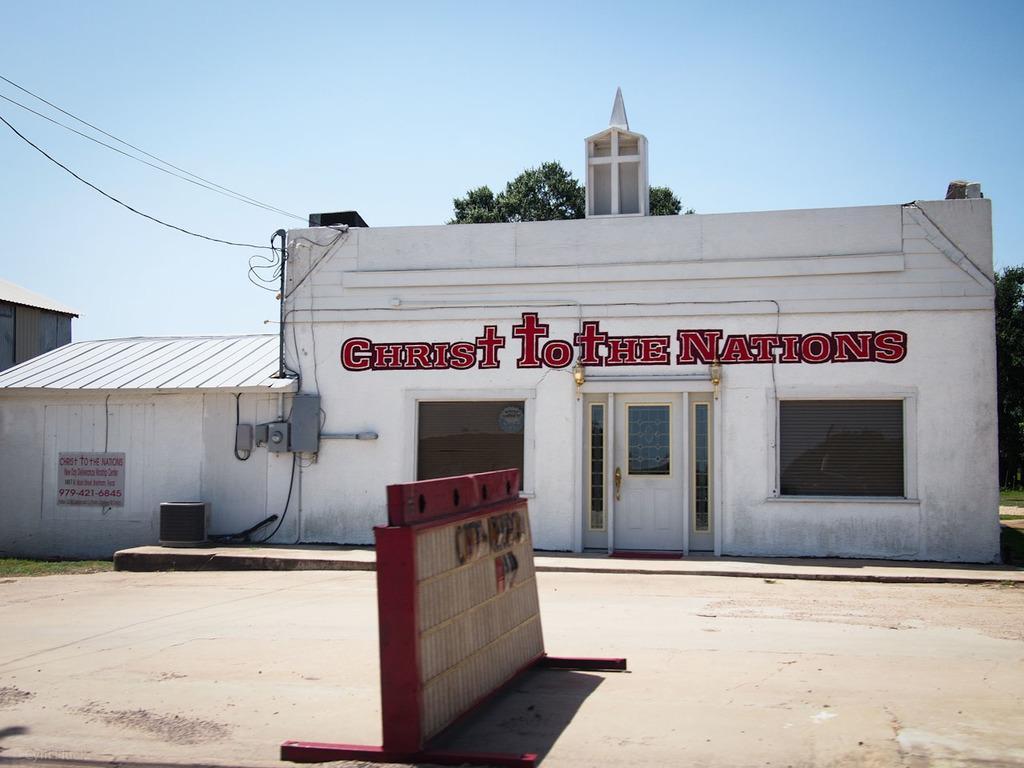Could you give a brief overview of what you see in this image? In this image we can see the church with the text, door and also the windows. We can also see a barrier on the road. In the background we can see the trees, electrical wires and also the sky. 